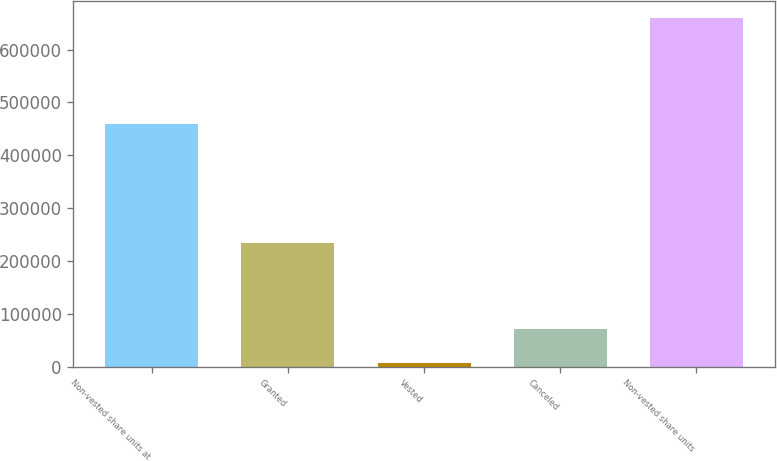Convert chart. <chart><loc_0><loc_0><loc_500><loc_500><bar_chart><fcel>Non-vested share units at<fcel>Granted<fcel>Vested<fcel>Canceled<fcel>Non-vested share units<nl><fcel>459929<fcel>233831<fcel>7301<fcel>72459.5<fcel>658886<nl></chart> 